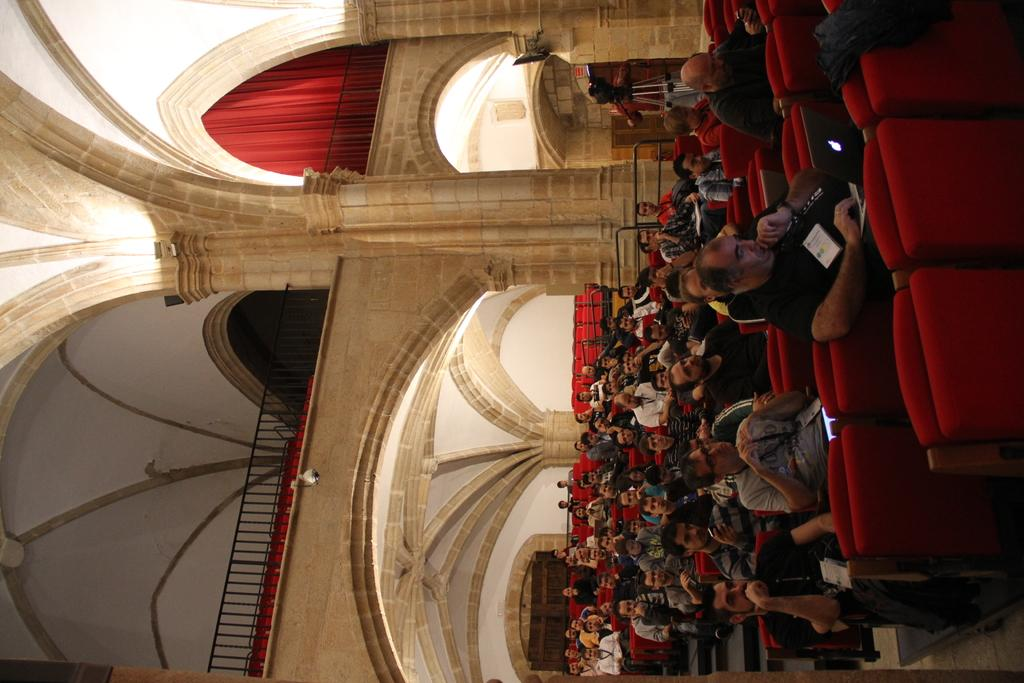What are the people in the image doing? The people in the image are seated on chairs. Can you describe the person holding an object in the image? There is a person holding a camera in the image. What color is the curtain visible in the image? There is a red curtain in the image. What type of slope can be seen in the image? There is no slope present in the image. How many sticks are visible in the image? There are no sticks visible in the image. 